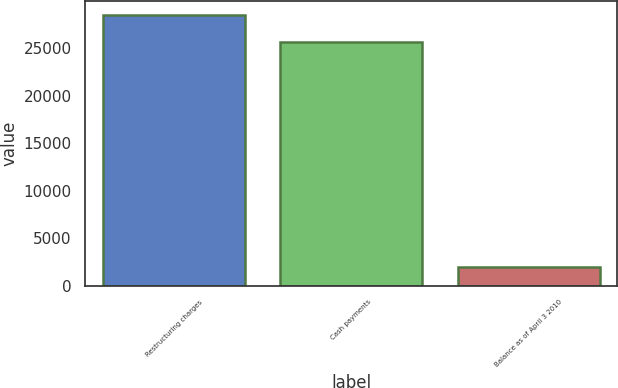<chart> <loc_0><loc_0><loc_500><loc_500><bar_chart><fcel>Restructuring charges<fcel>Cash payments<fcel>Balance as of April 3 2010<nl><fcel>28531<fcel>25633<fcel>1953<nl></chart> 